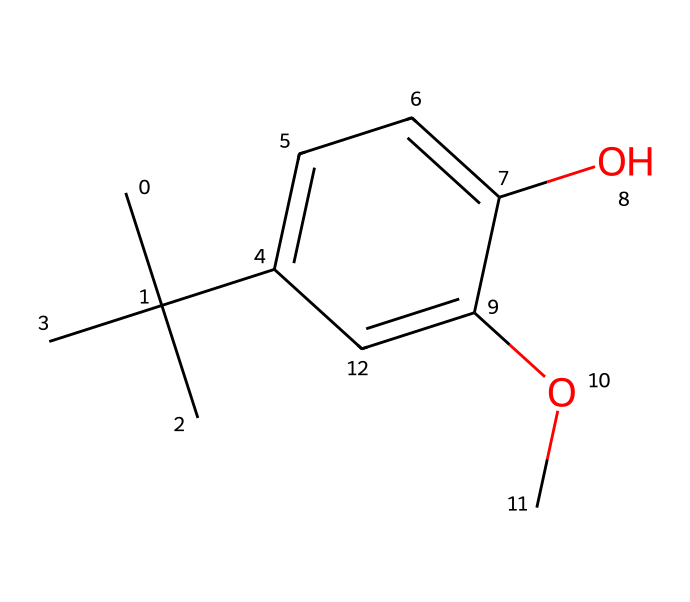What is the molecular formula of butylated hydroxyanisole? To determine the molecular formula, we need to count each type of atom present in the SMILES representation. Looking at the structure, we find that there are 10 carbon atoms, 14 hydrogen atoms, and 3 oxygen atoms. Therefore, the molecular formula is C10H14O3.
Answer: C10H14O3 How many hydroxyl (-OH) groups are present in the structure? The hydroxyl group is represented by "O" in the structure, which can be identified by the "O" directly connected to a carbon atom. In the provided SMILES, there is one "O" that is part of a -OH group. Thus, there is one hydroxyl group present.
Answer: 1 What type of compound is butylated hydroxyanisole classified as? Butylated hydroxyanisole has a branched structure with a hydroxyl group and an ether group (-O-). This combination classifies it primarily as an antioxidant used for preservation.
Answer: antioxidant How many aromatic rings are present in the molecule? To determine the number of aromatic rings, we look for cyclic structures that adhere to Huckel's rule (4n+2 π electrons). The provided structure contains a benzene ring, indicating there is one aromatic ring.
Answer: 1 Does this chemical contain any chiral centers? A chiral center is typically a carbon atom bonded to four different substituents. In this structure, we observe that the carbon at the branching point (the one connected to three other carbon atoms) does not meet the criteria for chirality, as it is bonded to two identical groups. Thus, there are no chiral centers.
Answer: no Is butylated hydroxyanisole water-soluble? Solubility can often be inferred from functional groups present. This compound has a hydroxyl group that generally enhances solubility in water, but it also contains a bulky aromatic portion which may limit solubility. However, it is generally considered to have low water solubility due to the hydrophobic nature of the aromatic system.
Answer: low What role does the methoxy (-OCH3) group play in the chemical structure? The methoxy group can enhance the compound's hydrophobic characteristics, stabilize the structure through resonance, and contribute to its antioxidant activity by participating in electron donation mechanisms.
Answer: enhances stability 